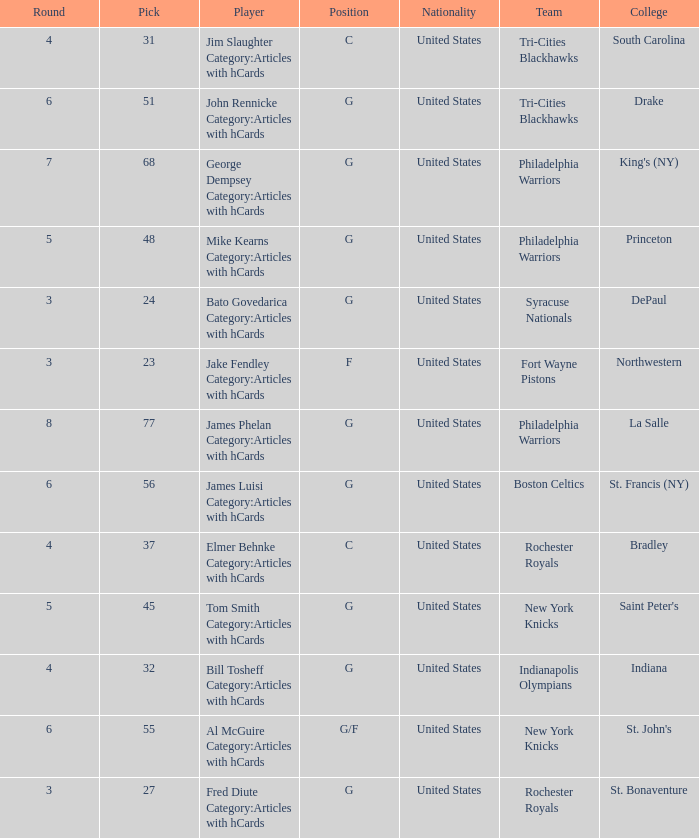What is the lowest pick number for players from king's (ny)? 68.0. 